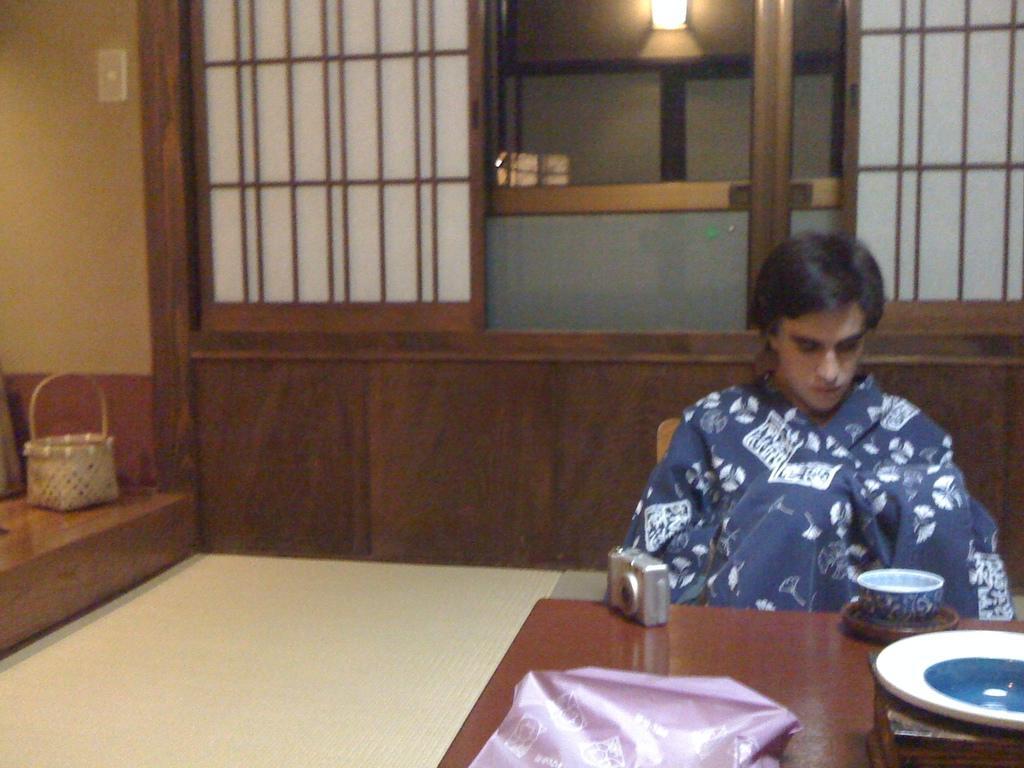Describe this image in one or two sentences. In this image I can see a person is sitting on a chair. Here on this table I can see a cup and a camera. In the background I can see a basket. 